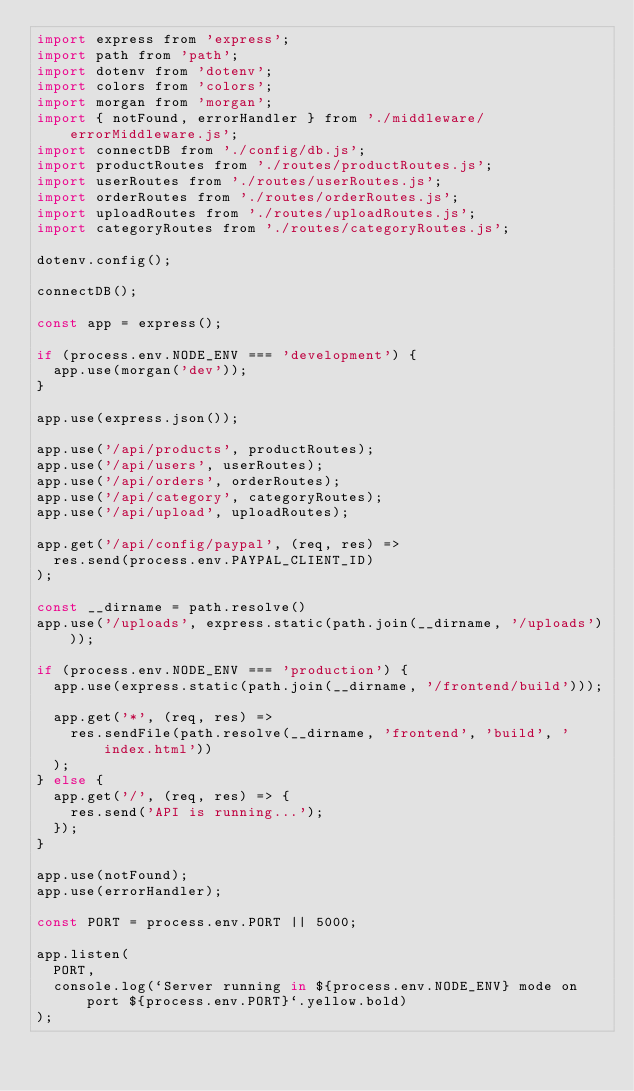Convert code to text. <code><loc_0><loc_0><loc_500><loc_500><_JavaScript_>import express from 'express';
import path from 'path';
import dotenv from 'dotenv';
import colors from 'colors';
import morgan from 'morgan';
import { notFound, errorHandler } from './middleware/errorMiddleware.js';
import connectDB from './config/db.js';
import productRoutes from './routes/productRoutes.js';
import userRoutes from './routes/userRoutes.js';
import orderRoutes from './routes/orderRoutes.js';
import uploadRoutes from './routes/uploadRoutes.js';
import categoryRoutes from './routes/categoryRoutes.js';

dotenv.config();

connectDB();

const app = express();

if (process.env.NODE_ENV === 'development') {
  app.use(morgan('dev'));
}

app.use(express.json());

app.use('/api/products', productRoutes);
app.use('/api/users', userRoutes);
app.use('/api/orders', orderRoutes);
app.use('/api/category', categoryRoutes);
app.use('/api/upload', uploadRoutes);

app.get('/api/config/paypal', (req, res) => 
  res.send(process.env.PAYPAL_CLIENT_ID)
);

const __dirname = path.resolve()
app.use('/uploads', express.static(path.join(__dirname, '/uploads')));

if (process.env.NODE_ENV === 'production') {
  app.use(express.static(path.join(__dirname, '/frontend/build')));

  app.get('*', (req, res) => 
    res.sendFile(path.resolve(__dirname, 'frontend', 'build', 'index.html'))
  );
} else {
  app.get('/', (req, res) => {
    res.send('API is running...');
  });
}

app.use(notFound);
app.use(errorHandler);

const PORT = process.env.PORT || 5000;

app.listen(
  PORT,
  console.log(`Server running in ${process.env.NODE_ENV} mode on port ${process.env.PORT}`.yellow.bold)
);
</code> 